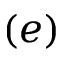Convert formula to latex. <formula><loc_0><loc_0><loc_500><loc_500>( e )</formula> 